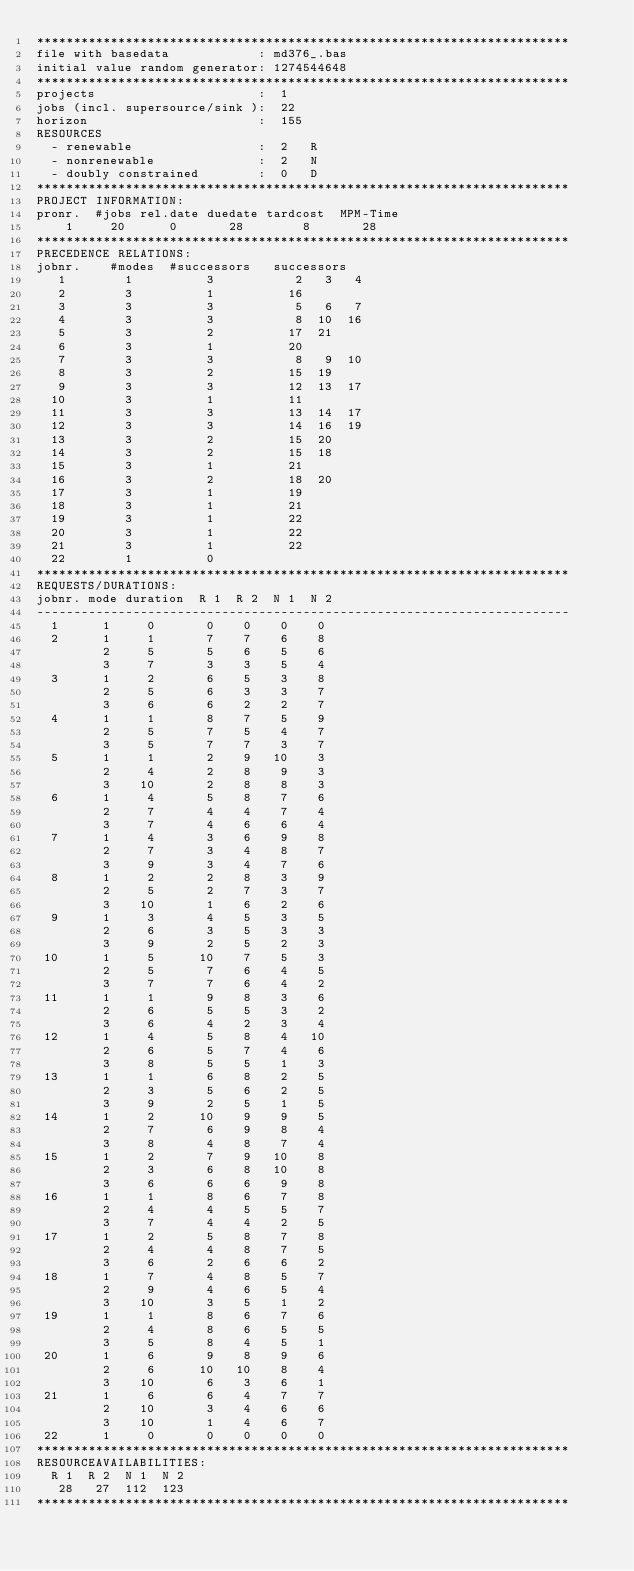<code> <loc_0><loc_0><loc_500><loc_500><_ObjectiveC_>************************************************************************
file with basedata            : md376_.bas
initial value random generator: 1274544648
************************************************************************
projects                      :  1
jobs (incl. supersource/sink ):  22
horizon                       :  155
RESOURCES
  - renewable                 :  2   R
  - nonrenewable              :  2   N
  - doubly constrained        :  0   D
************************************************************************
PROJECT INFORMATION:
pronr.  #jobs rel.date duedate tardcost  MPM-Time
    1     20      0       28        8       28
************************************************************************
PRECEDENCE RELATIONS:
jobnr.    #modes  #successors   successors
   1        1          3           2   3   4
   2        3          1          16
   3        3          3           5   6   7
   4        3          3           8  10  16
   5        3          2          17  21
   6        3          1          20
   7        3          3           8   9  10
   8        3          2          15  19
   9        3          3          12  13  17
  10        3          1          11
  11        3          3          13  14  17
  12        3          3          14  16  19
  13        3          2          15  20
  14        3          2          15  18
  15        3          1          21
  16        3          2          18  20
  17        3          1          19
  18        3          1          21
  19        3          1          22
  20        3          1          22
  21        3          1          22
  22        1          0        
************************************************************************
REQUESTS/DURATIONS:
jobnr. mode duration  R 1  R 2  N 1  N 2
------------------------------------------------------------------------
  1      1     0       0    0    0    0
  2      1     1       7    7    6    8
         2     5       5    6    5    6
         3     7       3    3    5    4
  3      1     2       6    5    3    8
         2     5       6    3    3    7
         3     6       6    2    2    7
  4      1     1       8    7    5    9
         2     5       7    5    4    7
         3     5       7    7    3    7
  5      1     1       2    9   10    3
         2     4       2    8    9    3
         3    10       2    8    8    3
  6      1     4       5    8    7    6
         2     7       4    4    7    4
         3     7       4    6    6    4
  7      1     4       3    6    9    8
         2     7       3    4    8    7
         3     9       3    4    7    6
  8      1     2       2    8    3    9
         2     5       2    7    3    7
         3    10       1    6    2    6
  9      1     3       4    5    3    5
         2     6       3    5    3    3
         3     9       2    5    2    3
 10      1     5      10    7    5    3
         2     5       7    6    4    5
         3     7       7    6    4    2
 11      1     1       9    8    3    6
         2     6       5    5    3    2
         3     6       4    2    3    4
 12      1     4       5    8    4   10
         2     6       5    7    4    6
         3     8       5    5    1    3
 13      1     1       6    8    2    5
         2     3       5    6    2    5
         3     9       2    5    1    5
 14      1     2      10    9    9    5
         2     7       6    9    8    4
         3     8       4    8    7    4
 15      1     2       7    9   10    8
         2     3       6    8   10    8
         3     6       6    6    9    8
 16      1     1       8    6    7    8
         2     4       4    5    5    7
         3     7       4    4    2    5
 17      1     2       5    8    7    8
         2     4       4    8    7    5
         3     6       2    6    6    2
 18      1     7       4    8    5    7
         2     9       4    6    5    4
         3    10       3    5    1    2
 19      1     1       8    6    7    6
         2     4       8    6    5    5
         3     5       8    4    5    1
 20      1     6       9    8    9    6
         2     6      10   10    8    4
         3    10       6    3    6    1
 21      1     6       6    4    7    7
         2    10       3    4    6    6
         3    10       1    4    6    7
 22      1     0       0    0    0    0
************************************************************************
RESOURCEAVAILABILITIES:
  R 1  R 2  N 1  N 2
   28   27  112  123
************************************************************************
</code> 